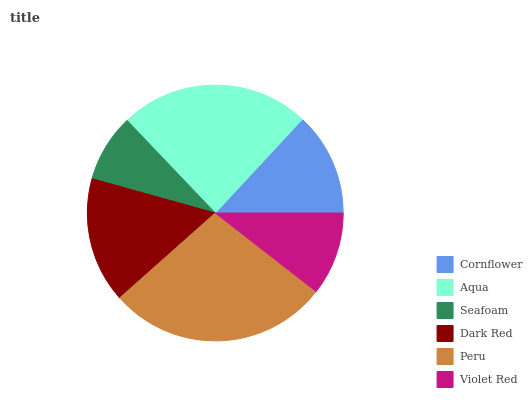Is Seafoam the minimum?
Answer yes or no. Yes. Is Peru the maximum?
Answer yes or no. Yes. Is Aqua the minimum?
Answer yes or no. No. Is Aqua the maximum?
Answer yes or no. No. Is Aqua greater than Cornflower?
Answer yes or no. Yes. Is Cornflower less than Aqua?
Answer yes or no. Yes. Is Cornflower greater than Aqua?
Answer yes or no. No. Is Aqua less than Cornflower?
Answer yes or no. No. Is Dark Red the high median?
Answer yes or no. Yes. Is Cornflower the low median?
Answer yes or no. Yes. Is Peru the high median?
Answer yes or no. No. Is Violet Red the low median?
Answer yes or no. No. 